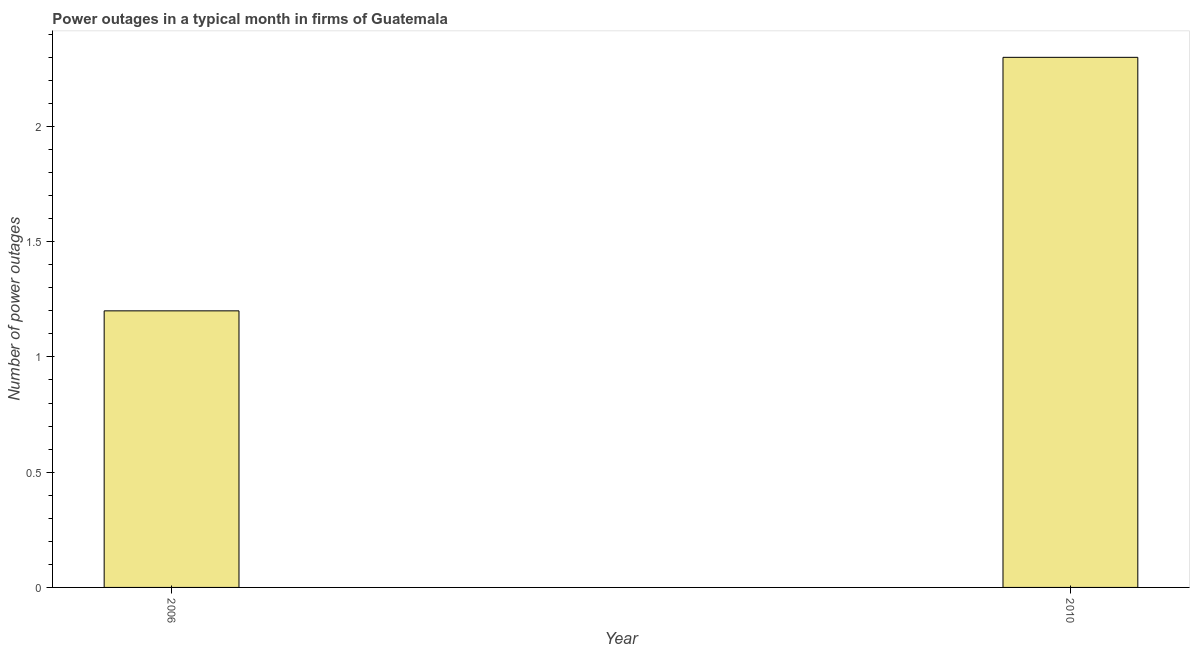Does the graph contain any zero values?
Ensure brevity in your answer.  No. Does the graph contain grids?
Ensure brevity in your answer.  No. What is the title of the graph?
Your answer should be very brief. Power outages in a typical month in firms of Guatemala. What is the label or title of the Y-axis?
Your answer should be compact. Number of power outages. Across all years, what is the maximum number of power outages?
Your answer should be compact. 2.3. What is the sum of the number of power outages?
Ensure brevity in your answer.  3.5. What is the median number of power outages?
Your answer should be compact. 1.75. What is the ratio of the number of power outages in 2006 to that in 2010?
Your answer should be very brief. 0.52. Is the number of power outages in 2006 less than that in 2010?
Give a very brief answer. Yes. In how many years, is the number of power outages greater than the average number of power outages taken over all years?
Offer a very short reply. 1. What is the difference between two consecutive major ticks on the Y-axis?
Your response must be concise. 0.5. What is the ratio of the Number of power outages in 2006 to that in 2010?
Your response must be concise. 0.52. 